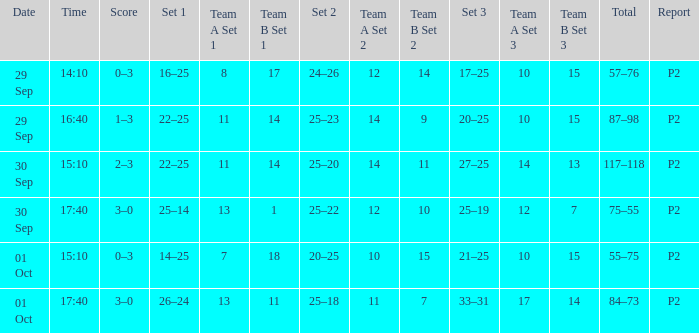What Score has a time of 14:10? 0–3. 